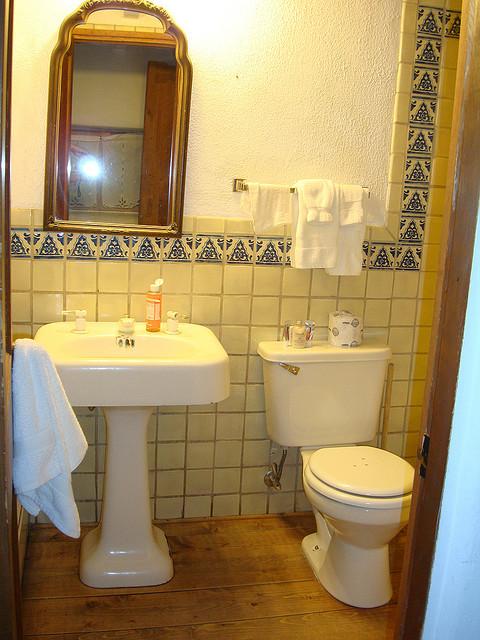What room is this?
Write a very short answer. Bathroom. Is the floor wood?
Short answer required. Yes. Is this an oval mirror?
Keep it brief. No. What is the backsplash made of?
Give a very brief answer. Tile. 